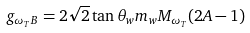Convert formula to latex. <formula><loc_0><loc_0><loc_500><loc_500>g _ { \omega _ { T } B } = 2 \sqrt { 2 } \tan \theta _ { w } m _ { w } M _ { \omega _ { T } } ( 2 A - 1 )</formula> 